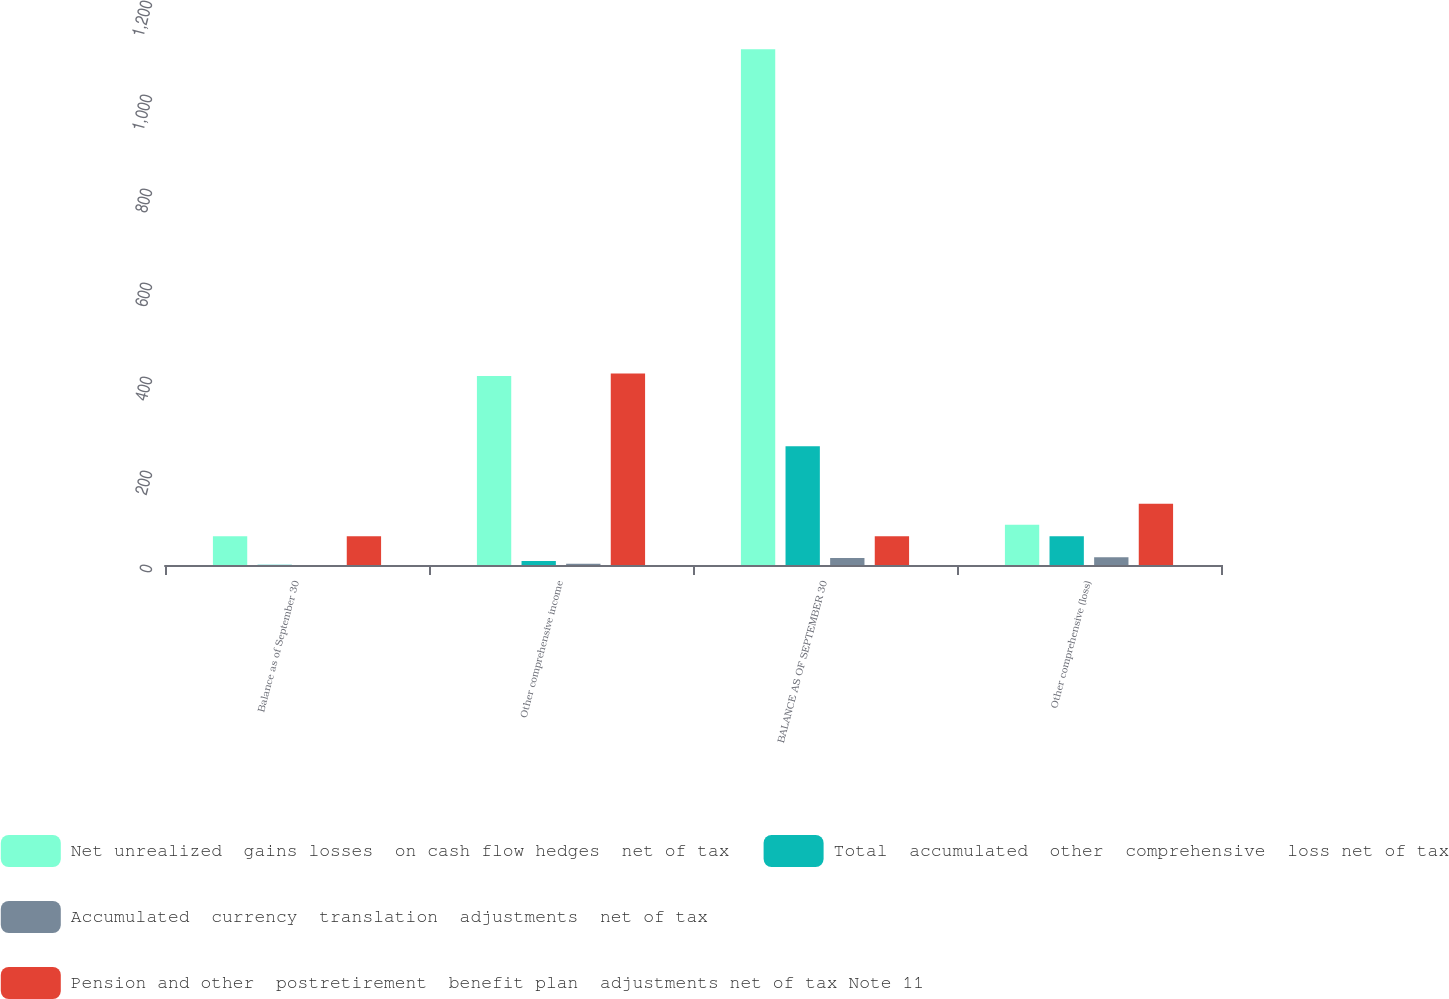Convert chart. <chart><loc_0><loc_0><loc_500><loc_500><stacked_bar_chart><ecel><fcel>Balance as of September 30<fcel>Other comprehensive income<fcel>BALANCE AS OF SEPTEMBER 30<fcel>Other comprehensive (loss)<nl><fcel>Net unrealized  gains losses  on cash flow hedges  net of tax<fcel>61.3<fcel>402.2<fcel>1097.1<fcel>85.6<nl><fcel>Total  accumulated  other  comprehensive  loss net of tax<fcel>0.5<fcel>8.3<fcel>252.4<fcel>61.3<nl><fcel>Accumulated  currency  translation  adjustments  net of tax<fcel>0.2<fcel>2.9<fcel>14.9<fcel>16.6<nl><fcel>Pension and other  postretirement  benefit plan  adjustments net of tax Note 11<fcel>61.3<fcel>407.6<fcel>61.3<fcel>130.3<nl></chart> 